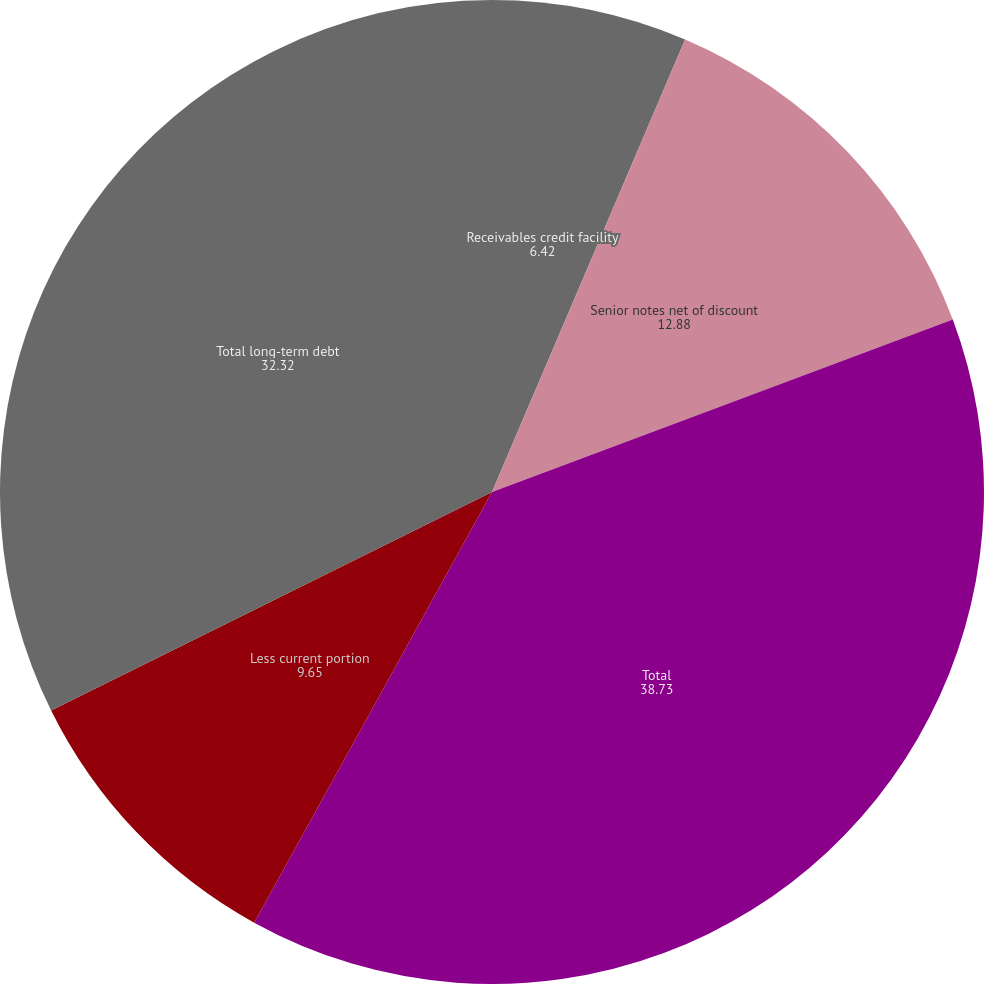Convert chart. <chart><loc_0><loc_0><loc_500><loc_500><pie_chart><fcel>Receivables credit facility<fcel>Senior notes net of discount<fcel>Total<fcel>Less current portion<fcel>Total long-term debt<nl><fcel>6.42%<fcel>12.88%<fcel>38.73%<fcel>9.65%<fcel>32.32%<nl></chart> 